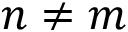<formula> <loc_0><loc_0><loc_500><loc_500>n \neq m</formula> 